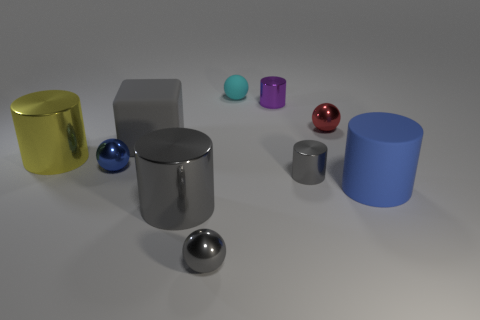How many objects in the image are not metallic in appearance? A total of five objects in the image do not exhibit a metallic appearance; they have more matte and colored finishes. 